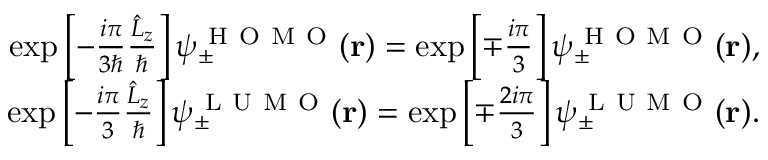<formula> <loc_0><loc_0><loc_500><loc_500>\begin{array} { r } { \exp \left [ - \frac { i \pi } { 3 } \frac { \hat { L } _ { z } } { } \right ] \psi _ { \pm } ^ { H O M O } ( r ) = \exp \left [ \mp \frac { i \pi } { 3 } \right ] \psi _ { \pm } ^ { H O M O } ( r ) , } \\ { \exp \left [ - \frac { i \pi } { 3 } \frac { \hat { L } _ { z } } { } \right ] \psi _ { \pm } ^ { L U M O } ( r ) = \exp \left [ \mp \frac { 2 i \pi } { 3 } \right ] \psi _ { \pm } ^ { L U M O } ( r ) . } \end{array}</formula> 